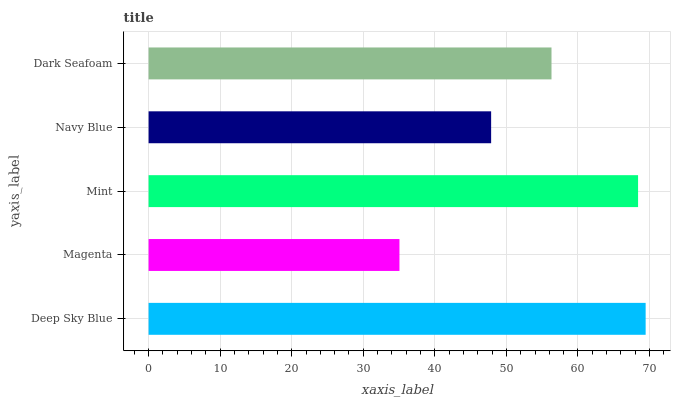Is Magenta the minimum?
Answer yes or no. Yes. Is Deep Sky Blue the maximum?
Answer yes or no. Yes. Is Mint the minimum?
Answer yes or no. No. Is Mint the maximum?
Answer yes or no. No. Is Mint greater than Magenta?
Answer yes or no. Yes. Is Magenta less than Mint?
Answer yes or no. Yes. Is Magenta greater than Mint?
Answer yes or no. No. Is Mint less than Magenta?
Answer yes or no. No. Is Dark Seafoam the high median?
Answer yes or no. Yes. Is Dark Seafoam the low median?
Answer yes or no. Yes. Is Deep Sky Blue the high median?
Answer yes or no. No. Is Navy Blue the low median?
Answer yes or no. No. 